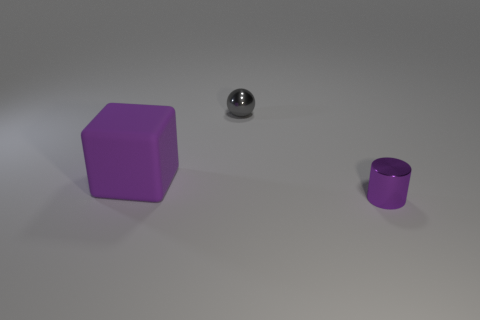There is a metallic thing in front of the purple matte cube; what number of things are behind it?
Ensure brevity in your answer.  2. What is the shape of the object that is both in front of the small metal ball and to the right of the purple cube?
Offer a very short reply. Cylinder. What number of metallic objects are the same color as the rubber cube?
Ensure brevity in your answer.  1. Is there a tiny purple cylinder that is left of the small thing to the right of the small thing left of the purple shiny thing?
Provide a short and direct response. No. There is a thing that is to the left of the small shiny cylinder and in front of the ball; what size is it?
Offer a very short reply. Large. What number of tiny things are made of the same material as the ball?
Make the answer very short. 1. How many cylinders are rubber objects or tiny gray objects?
Give a very brief answer. 0. There is a purple object that is in front of the purple object that is to the left of the purple object on the right side of the purple matte thing; how big is it?
Your answer should be very brief. Small. The thing that is both behind the purple metallic cylinder and right of the large purple matte thing is what color?
Offer a terse response. Gray. There is a gray metallic ball; is it the same size as the thing that is in front of the rubber block?
Offer a very short reply. Yes. 